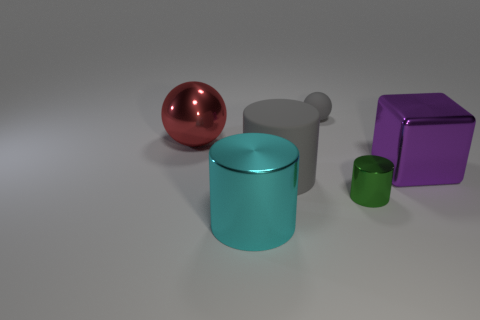Add 3 big metallic cubes. How many objects exist? 9 Subtract all gray cylinders. How many cylinders are left? 2 Subtract all shiny cylinders. How many cylinders are left? 1 Subtract all spheres. How many objects are left? 4 Subtract 2 cylinders. How many cylinders are left? 1 Subtract all purple balls. Subtract all cyan cylinders. How many balls are left? 2 Subtract all red balls. How many green cylinders are left? 1 Subtract all red metallic things. Subtract all big objects. How many objects are left? 1 Add 3 small shiny objects. How many small shiny objects are left? 4 Add 6 big gray matte things. How many big gray matte things exist? 7 